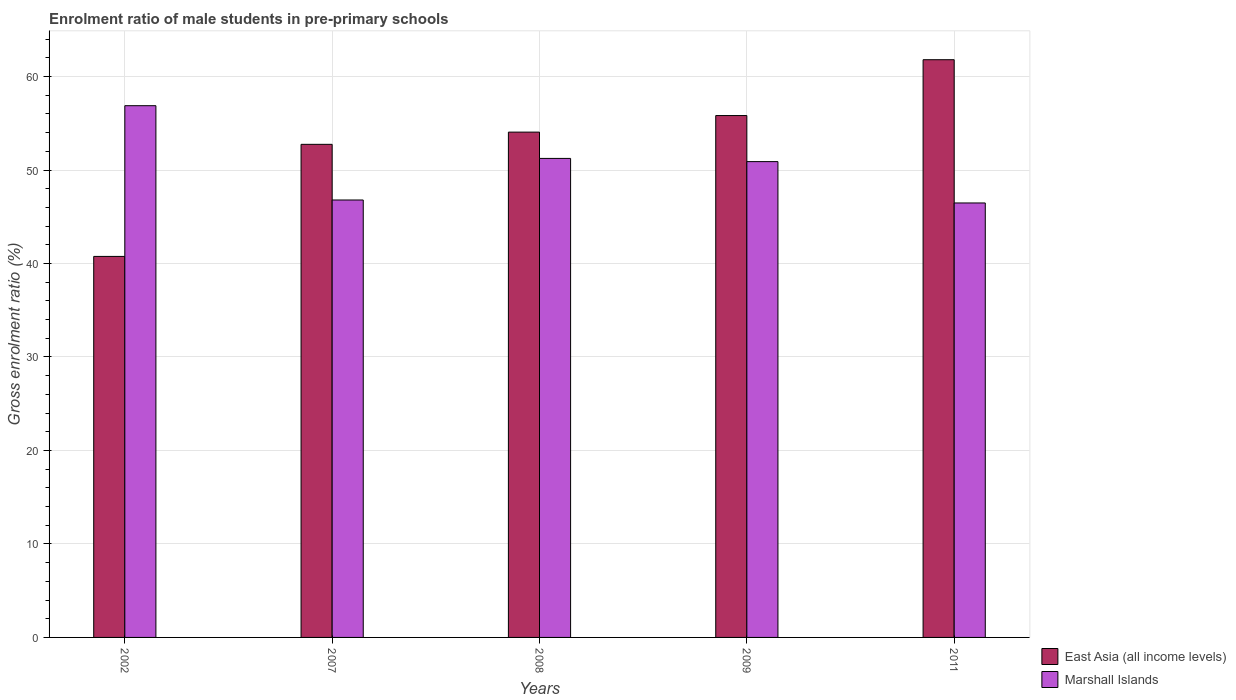How many different coloured bars are there?
Make the answer very short. 2. How many groups of bars are there?
Keep it short and to the point. 5. Are the number of bars per tick equal to the number of legend labels?
Offer a very short reply. Yes. What is the enrolment ratio of male students in pre-primary schools in Marshall Islands in 2007?
Your answer should be very brief. 46.8. Across all years, what is the maximum enrolment ratio of male students in pre-primary schools in East Asia (all income levels)?
Provide a succinct answer. 61.8. Across all years, what is the minimum enrolment ratio of male students in pre-primary schools in East Asia (all income levels)?
Give a very brief answer. 40.76. What is the total enrolment ratio of male students in pre-primary schools in East Asia (all income levels) in the graph?
Provide a short and direct response. 265.2. What is the difference between the enrolment ratio of male students in pre-primary schools in Marshall Islands in 2002 and that in 2009?
Give a very brief answer. 5.98. What is the difference between the enrolment ratio of male students in pre-primary schools in East Asia (all income levels) in 2008 and the enrolment ratio of male students in pre-primary schools in Marshall Islands in 2007?
Make the answer very short. 7.26. What is the average enrolment ratio of male students in pre-primary schools in East Asia (all income levels) per year?
Your response must be concise. 53.04. In the year 2011, what is the difference between the enrolment ratio of male students in pre-primary schools in East Asia (all income levels) and enrolment ratio of male students in pre-primary schools in Marshall Islands?
Give a very brief answer. 15.32. What is the ratio of the enrolment ratio of male students in pre-primary schools in Marshall Islands in 2009 to that in 2011?
Make the answer very short. 1.1. What is the difference between the highest and the second highest enrolment ratio of male students in pre-primary schools in East Asia (all income levels)?
Offer a terse response. 5.97. What is the difference between the highest and the lowest enrolment ratio of male students in pre-primary schools in Marshall Islands?
Offer a terse response. 10.41. In how many years, is the enrolment ratio of male students in pre-primary schools in Marshall Islands greater than the average enrolment ratio of male students in pre-primary schools in Marshall Islands taken over all years?
Give a very brief answer. 3. What does the 2nd bar from the left in 2002 represents?
Ensure brevity in your answer.  Marshall Islands. What does the 2nd bar from the right in 2002 represents?
Your answer should be compact. East Asia (all income levels). How many bars are there?
Make the answer very short. 10. Are all the bars in the graph horizontal?
Your answer should be compact. No. How many years are there in the graph?
Keep it short and to the point. 5. Does the graph contain any zero values?
Ensure brevity in your answer.  No. Where does the legend appear in the graph?
Give a very brief answer. Bottom right. How many legend labels are there?
Ensure brevity in your answer.  2. What is the title of the graph?
Your answer should be compact. Enrolment ratio of male students in pre-primary schools. What is the label or title of the Y-axis?
Provide a short and direct response. Gross enrolment ratio (%). What is the Gross enrolment ratio (%) in East Asia (all income levels) in 2002?
Ensure brevity in your answer.  40.76. What is the Gross enrolment ratio (%) in Marshall Islands in 2002?
Give a very brief answer. 56.88. What is the Gross enrolment ratio (%) in East Asia (all income levels) in 2007?
Provide a short and direct response. 52.75. What is the Gross enrolment ratio (%) in Marshall Islands in 2007?
Your response must be concise. 46.8. What is the Gross enrolment ratio (%) in East Asia (all income levels) in 2008?
Make the answer very short. 54.06. What is the Gross enrolment ratio (%) in Marshall Islands in 2008?
Offer a very short reply. 51.24. What is the Gross enrolment ratio (%) of East Asia (all income levels) in 2009?
Give a very brief answer. 55.83. What is the Gross enrolment ratio (%) of Marshall Islands in 2009?
Provide a short and direct response. 50.9. What is the Gross enrolment ratio (%) in East Asia (all income levels) in 2011?
Your answer should be compact. 61.8. What is the Gross enrolment ratio (%) in Marshall Islands in 2011?
Keep it short and to the point. 46.48. Across all years, what is the maximum Gross enrolment ratio (%) of East Asia (all income levels)?
Provide a short and direct response. 61.8. Across all years, what is the maximum Gross enrolment ratio (%) in Marshall Islands?
Your answer should be compact. 56.88. Across all years, what is the minimum Gross enrolment ratio (%) of East Asia (all income levels)?
Your response must be concise. 40.76. Across all years, what is the minimum Gross enrolment ratio (%) in Marshall Islands?
Provide a short and direct response. 46.48. What is the total Gross enrolment ratio (%) of East Asia (all income levels) in the graph?
Keep it short and to the point. 265.2. What is the total Gross enrolment ratio (%) of Marshall Islands in the graph?
Keep it short and to the point. 252.31. What is the difference between the Gross enrolment ratio (%) in East Asia (all income levels) in 2002 and that in 2007?
Make the answer very short. -11.99. What is the difference between the Gross enrolment ratio (%) of Marshall Islands in 2002 and that in 2007?
Offer a very short reply. 10.09. What is the difference between the Gross enrolment ratio (%) of East Asia (all income levels) in 2002 and that in 2008?
Provide a short and direct response. -13.3. What is the difference between the Gross enrolment ratio (%) of Marshall Islands in 2002 and that in 2008?
Your answer should be very brief. 5.64. What is the difference between the Gross enrolment ratio (%) in East Asia (all income levels) in 2002 and that in 2009?
Give a very brief answer. -15.07. What is the difference between the Gross enrolment ratio (%) of Marshall Islands in 2002 and that in 2009?
Your answer should be very brief. 5.98. What is the difference between the Gross enrolment ratio (%) of East Asia (all income levels) in 2002 and that in 2011?
Your response must be concise. -21.04. What is the difference between the Gross enrolment ratio (%) of Marshall Islands in 2002 and that in 2011?
Keep it short and to the point. 10.41. What is the difference between the Gross enrolment ratio (%) of East Asia (all income levels) in 2007 and that in 2008?
Ensure brevity in your answer.  -1.31. What is the difference between the Gross enrolment ratio (%) in Marshall Islands in 2007 and that in 2008?
Your answer should be very brief. -4.45. What is the difference between the Gross enrolment ratio (%) in East Asia (all income levels) in 2007 and that in 2009?
Provide a succinct answer. -3.08. What is the difference between the Gross enrolment ratio (%) in Marshall Islands in 2007 and that in 2009?
Provide a succinct answer. -4.1. What is the difference between the Gross enrolment ratio (%) in East Asia (all income levels) in 2007 and that in 2011?
Offer a very short reply. -9.05. What is the difference between the Gross enrolment ratio (%) of Marshall Islands in 2007 and that in 2011?
Provide a short and direct response. 0.32. What is the difference between the Gross enrolment ratio (%) of East Asia (all income levels) in 2008 and that in 2009?
Offer a very short reply. -1.77. What is the difference between the Gross enrolment ratio (%) in Marshall Islands in 2008 and that in 2009?
Your answer should be compact. 0.34. What is the difference between the Gross enrolment ratio (%) of East Asia (all income levels) in 2008 and that in 2011?
Your response must be concise. -7.75. What is the difference between the Gross enrolment ratio (%) in Marshall Islands in 2008 and that in 2011?
Your answer should be very brief. 4.76. What is the difference between the Gross enrolment ratio (%) of East Asia (all income levels) in 2009 and that in 2011?
Your answer should be compact. -5.97. What is the difference between the Gross enrolment ratio (%) in Marshall Islands in 2009 and that in 2011?
Offer a terse response. 4.42. What is the difference between the Gross enrolment ratio (%) in East Asia (all income levels) in 2002 and the Gross enrolment ratio (%) in Marshall Islands in 2007?
Make the answer very short. -6.04. What is the difference between the Gross enrolment ratio (%) in East Asia (all income levels) in 2002 and the Gross enrolment ratio (%) in Marshall Islands in 2008?
Your response must be concise. -10.48. What is the difference between the Gross enrolment ratio (%) in East Asia (all income levels) in 2002 and the Gross enrolment ratio (%) in Marshall Islands in 2009?
Your response must be concise. -10.14. What is the difference between the Gross enrolment ratio (%) in East Asia (all income levels) in 2002 and the Gross enrolment ratio (%) in Marshall Islands in 2011?
Ensure brevity in your answer.  -5.72. What is the difference between the Gross enrolment ratio (%) in East Asia (all income levels) in 2007 and the Gross enrolment ratio (%) in Marshall Islands in 2008?
Your answer should be very brief. 1.51. What is the difference between the Gross enrolment ratio (%) of East Asia (all income levels) in 2007 and the Gross enrolment ratio (%) of Marshall Islands in 2009?
Provide a short and direct response. 1.85. What is the difference between the Gross enrolment ratio (%) of East Asia (all income levels) in 2007 and the Gross enrolment ratio (%) of Marshall Islands in 2011?
Provide a succinct answer. 6.27. What is the difference between the Gross enrolment ratio (%) in East Asia (all income levels) in 2008 and the Gross enrolment ratio (%) in Marshall Islands in 2009?
Your answer should be compact. 3.16. What is the difference between the Gross enrolment ratio (%) of East Asia (all income levels) in 2008 and the Gross enrolment ratio (%) of Marshall Islands in 2011?
Make the answer very short. 7.58. What is the difference between the Gross enrolment ratio (%) in East Asia (all income levels) in 2009 and the Gross enrolment ratio (%) in Marshall Islands in 2011?
Give a very brief answer. 9.35. What is the average Gross enrolment ratio (%) in East Asia (all income levels) per year?
Your response must be concise. 53.04. What is the average Gross enrolment ratio (%) in Marshall Islands per year?
Give a very brief answer. 50.46. In the year 2002, what is the difference between the Gross enrolment ratio (%) in East Asia (all income levels) and Gross enrolment ratio (%) in Marshall Islands?
Your response must be concise. -16.12. In the year 2007, what is the difference between the Gross enrolment ratio (%) of East Asia (all income levels) and Gross enrolment ratio (%) of Marshall Islands?
Provide a short and direct response. 5.95. In the year 2008, what is the difference between the Gross enrolment ratio (%) of East Asia (all income levels) and Gross enrolment ratio (%) of Marshall Islands?
Make the answer very short. 2.81. In the year 2009, what is the difference between the Gross enrolment ratio (%) of East Asia (all income levels) and Gross enrolment ratio (%) of Marshall Islands?
Your answer should be very brief. 4.93. In the year 2011, what is the difference between the Gross enrolment ratio (%) of East Asia (all income levels) and Gross enrolment ratio (%) of Marshall Islands?
Give a very brief answer. 15.32. What is the ratio of the Gross enrolment ratio (%) in East Asia (all income levels) in 2002 to that in 2007?
Ensure brevity in your answer.  0.77. What is the ratio of the Gross enrolment ratio (%) of Marshall Islands in 2002 to that in 2007?
Keep it short and to the point. 1.22. What is the ratio of the Gross enrolment ratio (%) in East Asia (all income levels) in 2002 to that in 2008?
Your response must be concise. 0.75. What is the ratio of the Gross enrolment ratio (%) in Marshall Islands in 2002 to that in 2008?
Your answer should be very brief. 1.11. What is the ratio of the Gross enrolment ratio (%) of East Asia (all income levels) in 2002 to that in 2009?
Your answer should be very brief. 0.73. What is the ratio of the Gross enrolment ratio (%) in Marshall Islands in 2002 to that in 2009?
Provide a short and direct response. 1.12. What is the ratio of the Gross enrolment ratio (%) of East Asia (all income levels) in 2002 to that in 2011?
Offer a terse response. 0.66. What is the ratio of the Gross enrolment ratio (%) of Marshall Islands in 2002 to that in 2011?
Provide a succinct answer. 1.22. What is the ratio of the Gross enrolment ratio (%) in East Asia (all income levels) in 2007 to that in 2008?
Provide a succinct answer. 0.98. What is the ratio of the Gross enrolment ratio (%) in Marshall Islands in 2007 to that in 2008?
Offer a very short reply. 0.91. What is the ratio of the Gross enrolment ratio (%) in East Asia (all income levels) in 2007 to that in 2009?
Your answer should be very brief. 0.94. What is the ratio of the Gross enrolment ratio (%) of Marshall Islands in 2007 to that in 2009?
Provide a short and direct response. 0.92. What is the ratio of the Gross enrolment ratio (%) of East Asia (all income levels) in 2007 to that in 2011?
Provide a succinct answer. 0.85. What is the ratio of the Gross enrolment ratio (%) in Marshall Islands in 2007 to that in 2011?
Your answer should be compact. 1.01. What is the ratio of the Gross enrolment ratio (%) in East Asia (all income levels) in 2008 to that in 2009?
Offer a terse response. 0.97. What is the ratio of the Gross enrolment ratio (%) in East Asia (all income levels) in 2008 to that in 2011?
Keep it short and to the point. 0.87. What is the ratio of the Gross enrolment ratio (%) in Marshall Islands in 2008 to that in 2011?
Give a very brief answer. 1.1. What is the ratio of the Gross enrolment ratio (%) in East Asia (all income levels) in 2009 to that in 2011?
Your answer should be very brief. 0.9. What is the ratio of the Gross enrolment ratio (%) in Marshall Islands in 2009 to that in 2011?
Provide a short and direct response. 1.1. What is the difference between the highest and the second highest Gross enrolment ratio (%) in East Asia (all income levels)?
Your answer should be compact. 5.97. What is the difference between the highest and the second highest Gross enrolment ratio (%) in Marshall Islands?
Ensure brevity in your answer.  5.64. What is the difference between the highest and the lowest Gross enrolment ratio (%) in East Asia (all income levels)?
Make the answer very short. 21.04. What is the difference between the highest and the lowest Gross enrolment ratio (%) in Marshall Islands?
Your answer should be very brief. 10.41. 